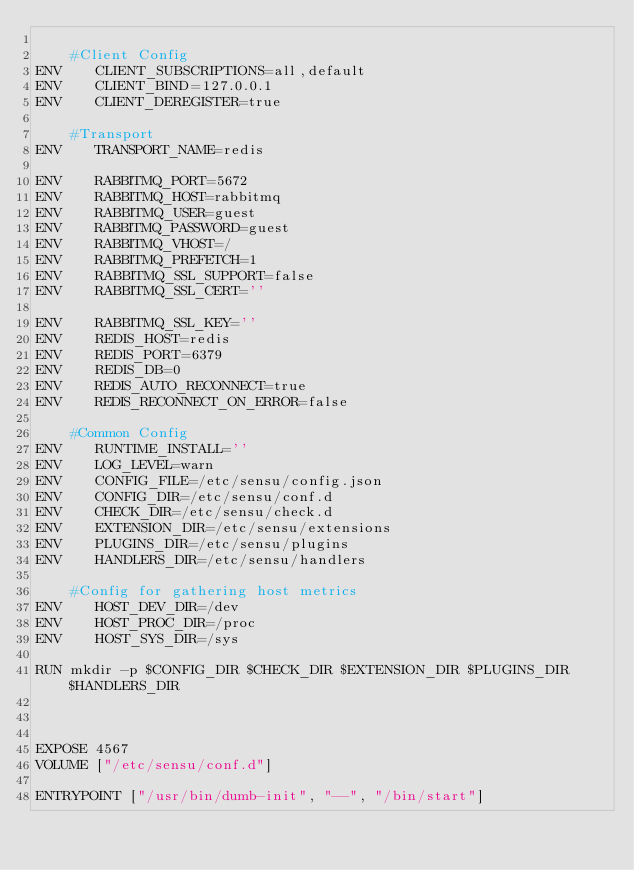Convert code to text. <code><loc_0><loc_0><loc_500><loc_500><_Dockerfile_>
    #Client Config
ENV    CLIENT_SUBSCRIPTIONS=all,default 
ENV    CLIENT_BIND=127.0.0.1 
ENV    CLIENT_DEREGISTER=true 

    #Transport
ENV    TRANSPORT_NAME=redis 

ENV    RABBITMQ_PORT=5672 
ENV    RABBITMQ_HOST=rabbitmq 
ENV    RABBITMQ_USER=guest 
ENV    RABBITMQ_PASSWORD=guest 
ENV    RABBITMQ_VHOST=/ 
ENV    RABBITMQ_PREFETCH=1 
ENV    RABBITMQ_SSL_SUPPORT=false 
ENV    RABBITMQ_SSL_CERT='' 

ENV    RABBITMQ_SSL_KEY='' 
ENV    REDIS_HOST=redis 
ENV    REDIS_PORT=6379 
ENV    REDIS_DB=0 
ENV    REDIS_AUTO_RECONNECT=true 
ENV    REDIS_RECONNECT_ON_ERROR=false 

    #Common Config
ENV    RUNTIME_INSTALL='' 
ENV    LOG_LEVEL=warn 
ENV    CONFIG_FILE=/etc/sensu/config.json 
ENV    CONFIG_DIR=/etc/sensu/conf.d 
ENV    CHECK_DIR=/etc/sensu/check.d 
ENV    EXTENSION_DIR=/etc/sensu/extensions 
ENV    PLUGINS_DIR=/etc/sensu/plugins 
ENV    HANDLERS_DIR=/etc/sensu/handlers 

    #Config for gathering host metrics
ENV    HOST_DEV_DIR=/dev 
ENV    HOST_PROC_DIR=/proc 
ENV    HOST_SYS_DIR=/sys

RUN mkdir -p $CONFIG_DIR $CHECK_DIR $EXTENSION_DIR $PLUGINS_DIR $HANDLERS_DIR



EXPOSE 4567
VOLUME ["/etc/sensu/conf.d"]

ENTRYPOINT ["/usr/bin/dumb-init", "--", "/bin/start"]
</code> 